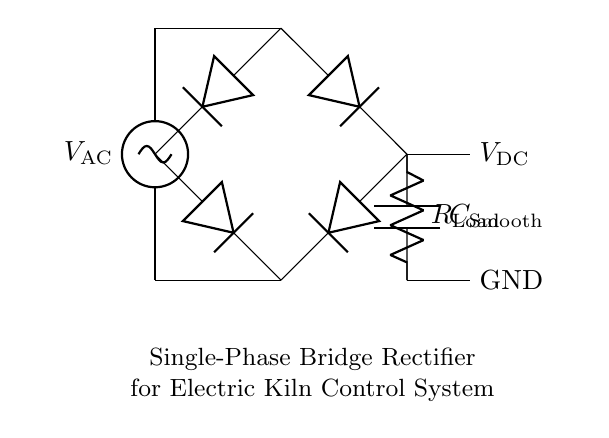What type of rectifier is shown in the diagram? The circuit diagram shows a bridge rectifier, which consists of four diodes arranged to efficiently convert AC input to DC output.
Answer: Bridge rectifier What is the function of the capacitor in the circuit? The capacitor smooths out the pulses of DC voltage by charging when the voltage rises and discharging when it drops, leading to a more stable DC output.
Answer: Smoothing How many diodes are present in the bridge rectifier? The circuit comprises four diodes, which facilitate the conversion of AC voltage to DC voltage by allowing current to flow in one direction only.
Answer: Four What does VDC represent in the circuit? VDC stands for the output voltage from the DC circuit after rectification, indicating the potential difference across the load resistor.
Answer: Output voltage What is the purpose of the load resistor? The load resistor is used to represent the resistance that the load connected to the permanent DC output will have, impacting the current flow through the circuit.
Answer: Load What type of current is being converted by this rectifier? The rectifier converts alternating current (AC) from the source into direct current (DC) suitable for the kiln's control system.
Answer: Alternating current What is the role of the AC source in this circuit? The AC source provides the initial voltage needed to activate the bridge rectifier, enabling it to convert this input into a usable DC voltage output.
Answer: Input voltage 